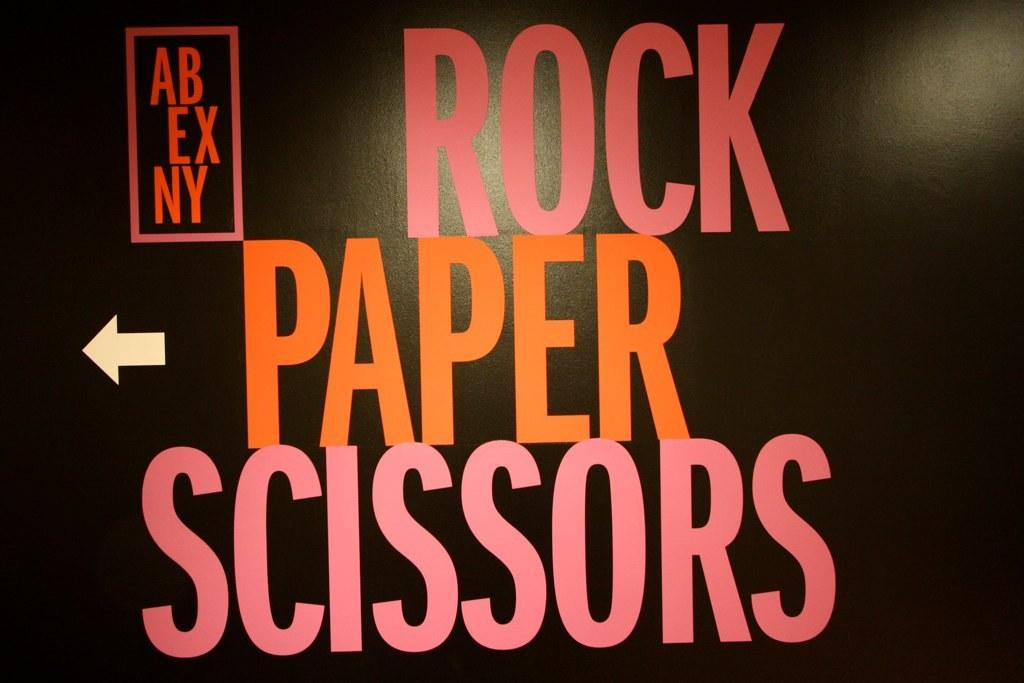Provide a one-sentence caption for the provided image. Black poster with Rock, Paper, Scissors written in bright letters on it. 